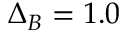Convert formula to latex. <formula><loc_0><loc_0><loc_500><loc_500>\Delta _ { B } = 1 . 0</formula> 